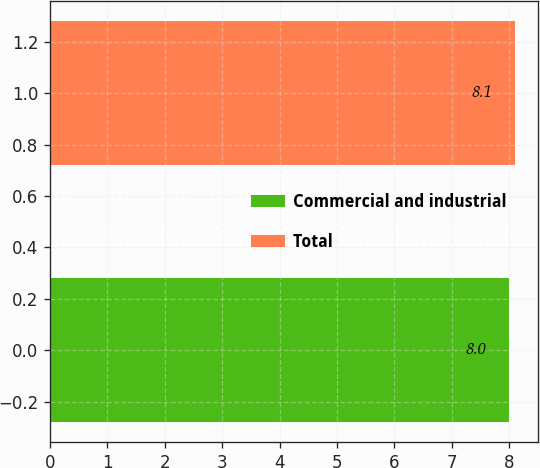<chart> <loc_0><loc_0><loc_500><loc_500><bar_chart><fcel>Commercial and industrial<fcel>Total<nl><fcel>8<fcel>8.1<nl></chart> 